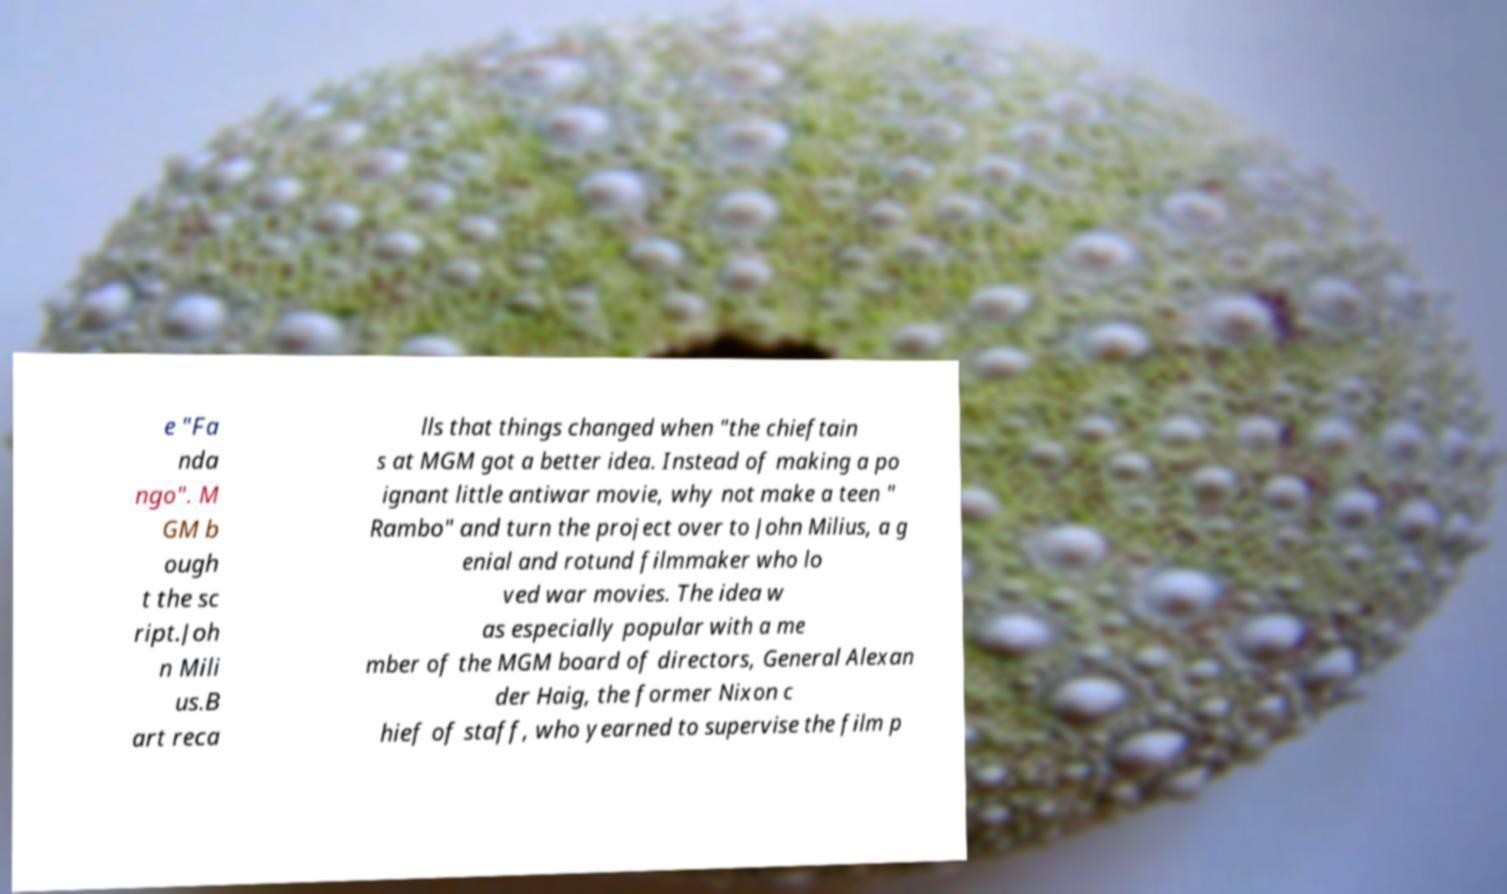Please identify and transcribe the text found in this image. e "Fa nda ngo". M GM b ough t the sc ript.Joh n Mili us.B art reca lls that things changed when "the chieftain s at MGM got a better idea. Instead of making a po ignant little antiwar movie, why not make a teen " Rambo" and turn the project over to John Milius, a g enial and rotund filmmaker who lo ved war movies. The idea w as especially popular with a me mber of the MGM board of directors, General Alexan der Haig, the former Nixon c hief of staff, who yearned to supervise the film p 